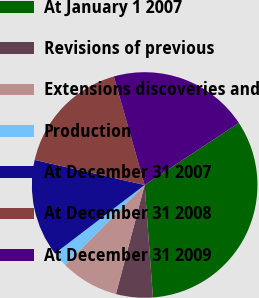Convert chart to OTSL. <chart><loc_0><loc_0><loc_500><loc_500><pie_chart><fcel>At January 1 2007<fcel>Revisions of previous<fcel>Extensions discoveries and<fcel>Production<fcel>At December 31 2007<fcel>At December 31 2008<fcel>At December 31 2009<nl><fcel>33.1%<fcel>5.27%<fcel>8.36%<fcel>2.17%<fcel>13.94%<fcel>17.03%<fcel>20.13%<nl></chart> 